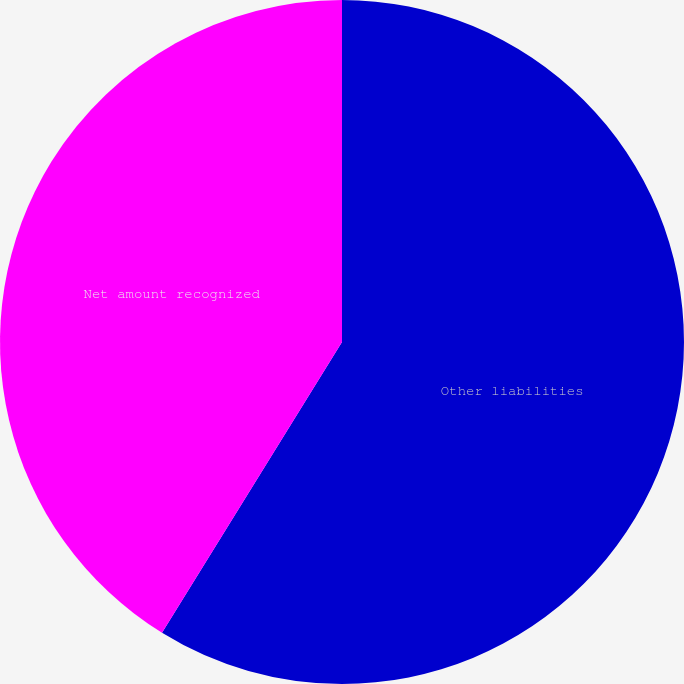Convert chart. <chart><loc_0><loc_0><loc_500><loc_500><pie_chart><fcel>Other liabilities<fcel>Net amount recognized<nl><fcel>58.82%<fcel>41.18%<nl></chart> 